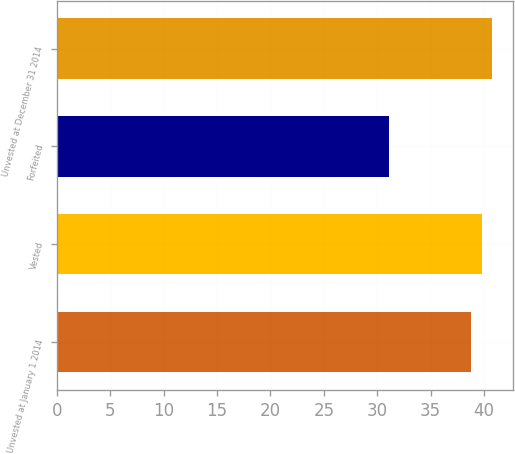Convert chart. <chart><loc_0><loc_0><loc_500><loc_500><bar_chart><fcel>Unvested at January 1 2014<fcel>Vested<fcel>Forfeited<fcel>Unvested at December 31 2014<nl><fcel>38.82<fcel>39.76<fcel>31.13<fcel>40.7<nl></chart> 